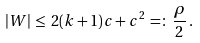Convert formula to latex. <formula><loc_0><loc_0><loc_500><loc_500>| W | \, \leq \, 2 ( k + 1 ) c + c ^ { 2 } \, = \colon \, \frac { \rho } { 2 } \, .</formula> 